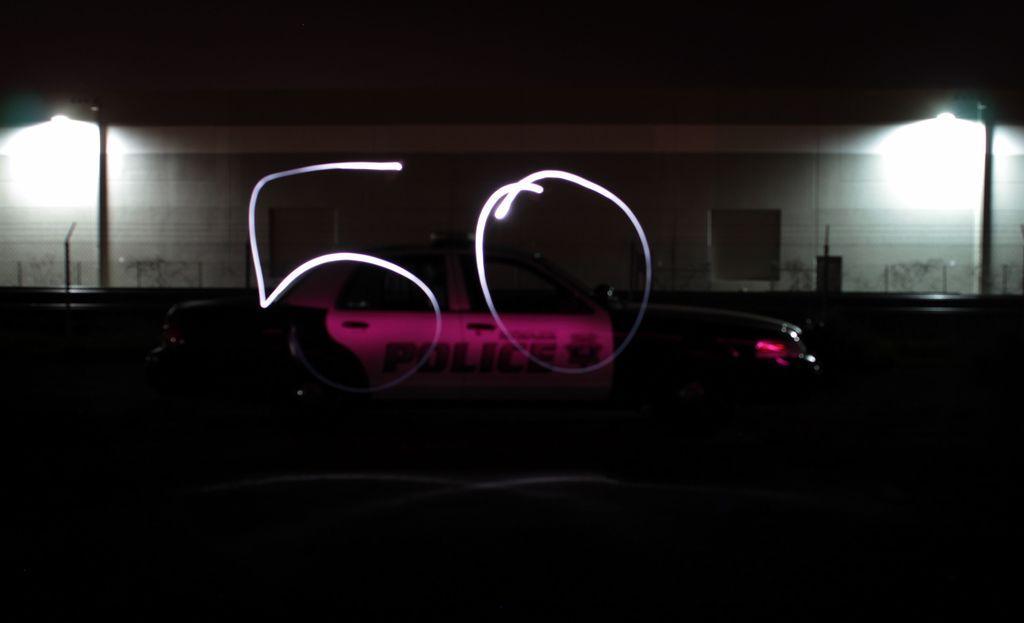Please provide a concise description of this image. In this picture I can see the number fifty on the glass. In the back there is a police car which is near parked near to the partition and building. On the right and left side I can see the street lights. At the top I can see the darkness. 